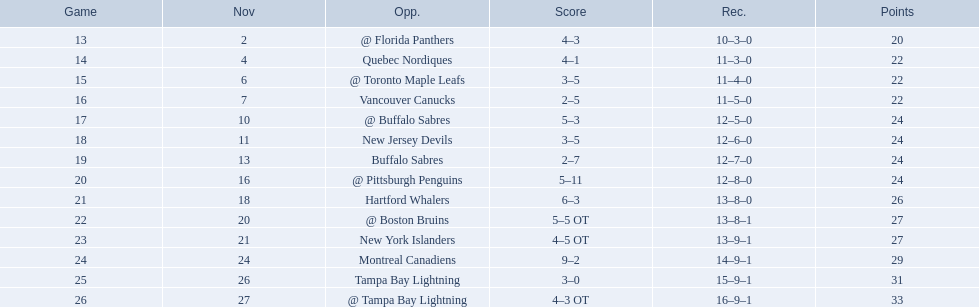Which teams scored 35 points or more in total? Hartford Whalers, @ Boston Bruins, New York Islanders, Montreal Canadiens, Tampa Bay Lightning, @ Tampa Bay Lightning. Of those teams, which team was the only one to score 3-0? Tampa Bay Lightning. 